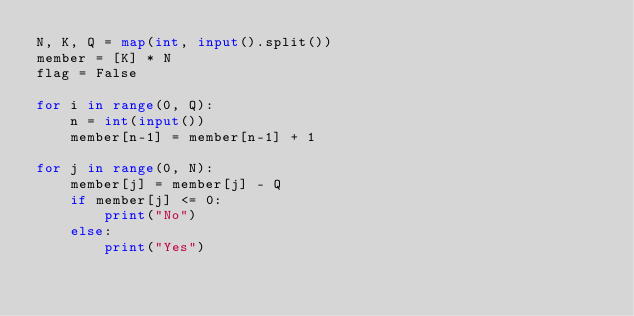<code> <loc_0><loc_0><loc_500><loc_500><_Python_>N, K, Q = map(int, input().split())
member = [K] * N
flag = False

for i in range(0, Q):
    n = int(input())
    member[n-1] = member[n-1] + 1

for j in range(0, N):
    member[j] = member[j] - Q
    if member[j] <= 0:
        print("No")
    else:
        print("Yes")
</code> 